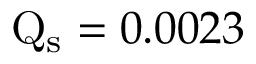Convert formula to latex. <formula><loc_0><loc_0><loc_500><loc_500>Q _ { s } = 0 . 0 0 2 3</formula> 